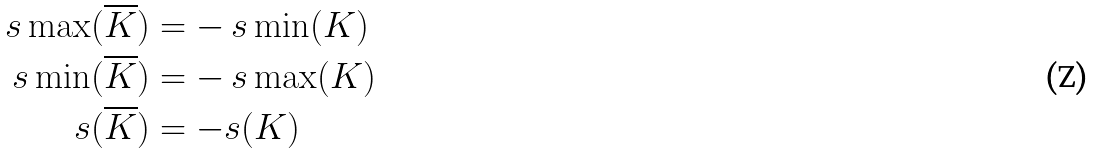Convert formula to latex. <formula><loc_0><loc_0><loc_500><loc_500>\ s \max ( \overline { K } ) & = - \ s \min ( K ) \\ \ s \min ( \overline { K } ) & = - \ s \max ( K ) \\ s ( \overline { K } ) & = - s ( K )</formula> 